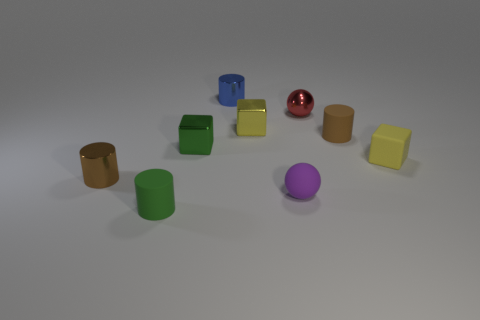There is a red ball; are there any yellow metal objects on the right side of it?
Your answer should be compact. No. Are there more large brown rubber cylinders than purple objects?
Your answer should be compact. No. There is a small metal cylinder that is behind the block on the right side of the small yellow thing that is on the left side of the tiny metallic sphere; what is its color?
Your answer should be very brief. Blue. There is a small block that is the same material as the purple ball; what is its color?
Give a very brief answer. Yellow. Are there any other things that are the same size as the green matte cylinder?
Your answer should be very brief. Yes. What number of things are either things on the right side of the metallic ball or tiny metallic objects on the left side of the small red thing?
Offer a very short reply. 6. There is a matte cylinder that is behind the small brown metal thing; is its size the same as the cylinder that is behind the red metal sphere?
Provide a short and direct response. Yes. There is another small matte object that is the same shape as the green matte object; what color is it?
Provide a succinct answer. Brown. Are there any other things that are the same shape as the tiny purple rubber object?
Offer a terse response. Yes. Is the number of small cylinders behind the yellow rubber block greater than the number of small metallic cylinders that are on the right side of the small green rubber object?
Your response must be concise. Yes. 